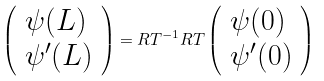<formula> <loc_0><loc_0><loc_500><loc_500>\left ( \begin{array} { l } \psi ( L ) \\ \psi ^ { \prime } ( L ) \end{array} \right ) = R T ^ { - 1 } R T \left ( \begin{array} { l } \psi ( 0 ) \\ \psi ^ { \prime } ( 0 ) \end{array} \right )</formula> 